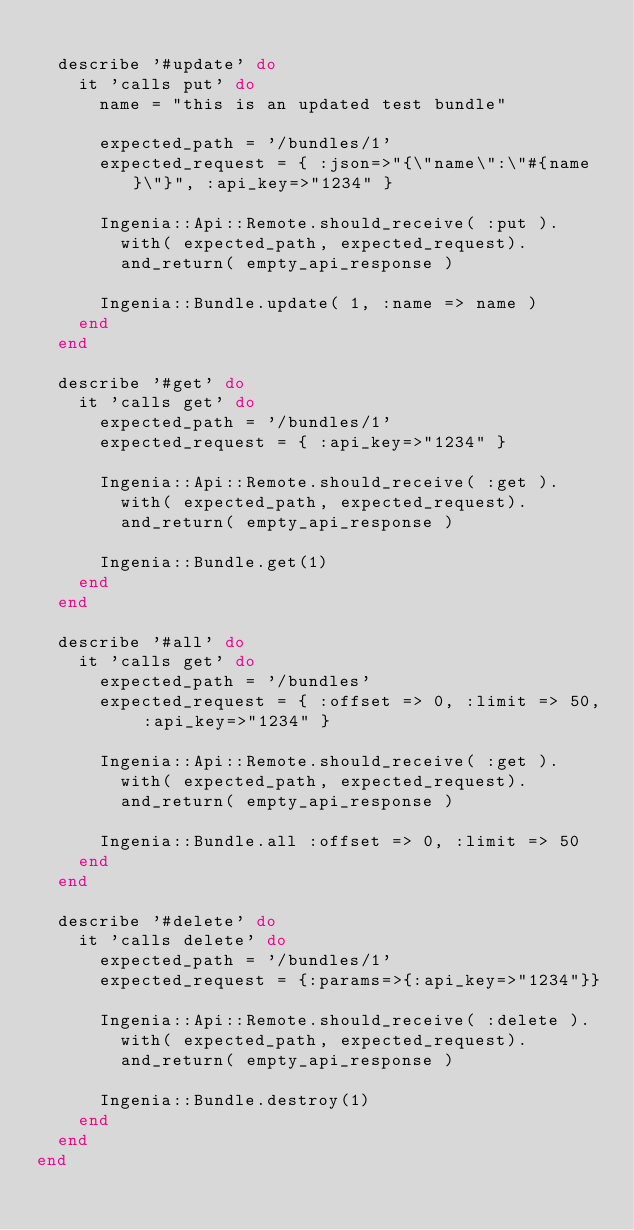<code> <loc_0><loc_0><loc_500><loc_500><_Ruby_>
  describe '#update' do
    it 'calls put' do
      name = "this is an updated test bundle"

      expected_path = '/bundles/1'
      expected_request = { :json=>"{\"name\":\"#{name}\"}", :api_key=>"1234" }

      Ingenia::Api::Remote.should_receive( :put ).
        with( expected_path, expected_request).
        and_return( empty_api_response )

      Ingenia::Bundle.update( 1, :name => name )
    end
  end

  describe '#get' do
    it 'calls get' do
      expected_path = '/bundles/1'
      expected_request = { :api_key=>"1234" }

      Ingenia::Api::Remote.should_receive( :get ).
        with( expected_path, expected_request).
        and_return( empty_api_response )

      Ingenia::Bundle.get(1)
    end
  end

  describe '#all' do
    it 'calls get' do
      expected_path = '/bundles'
      expected_request = { :offset => 0, :limit => 50, :api_key=>"1234" }

      Ingenia::Api::Remote.should_receive( :get ).
        with( expected_path, expected_request).
        and_return( empty_api_response )

      Ingenia::Bundle.all :offset => 0, :limit => 50
    end
  end

  describe '#delete' do
    it 'calls delete' do
      expected_path = '/bundles/1'
      expected_request = {:params=>{:api_key=>"1234"}} 

      Ingenia::Api::Remote.should_receive( :delete ).
        with( expected_path, expected_request).
        and_return( empty_api_response )

      Ingenia::Bundle.destroy(1)
    end
  end
end


</code> 